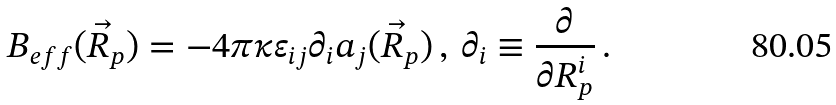<formula> <loc_0><loc_0><loc_500><loc_500>B _ { e f f } ( \vec { R } _ { p } ) = - 4 \pi \kappa \varepsilon _ { i j } \partial _ { i } a _ { j } ( \vec { R } _ { p } ) \, , \, \partial _ { i } \equiv \frac { \partial } { \partial R ^ { i } _ { p } } \, .</formula> 